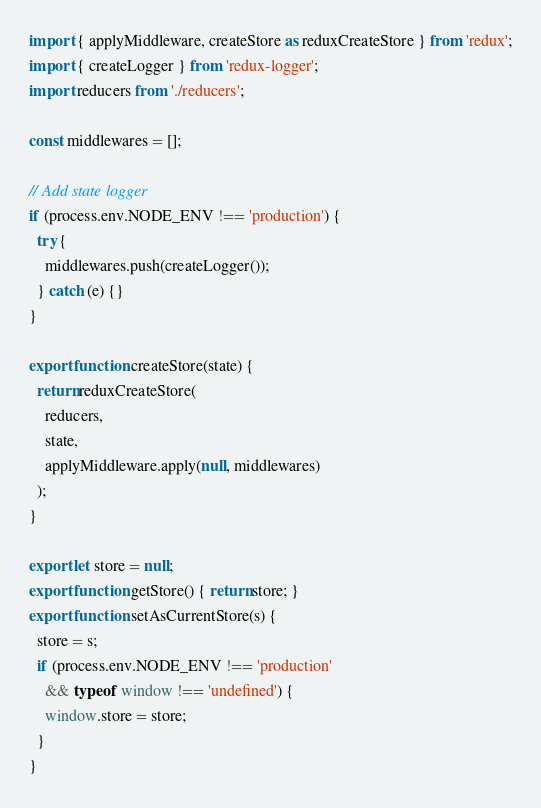<code> <loc_0><loc_0><loc_500><loc_500><_JavaScript_>import { applyMiddleware, createStore as reduxCreateStore } from 'redux';
import { createLogger } from 'redux-logger';
import reducers from './reducers';

const middlewares = [];

// Add state logger
if (process.env.NODE_ENV !== 'production') {
  try {
    middlewares.push(createLogger());
  } catch (e) {}
}

export function createStore(state) {
  return reduxCreateStore(
    reducers,
    state,
    applyMiddleware.apply(null, middlewares)
  );
}

export let store = null;
export function getStore() { return store; }
export function setAsCurrentStore(s) {
  store = s;
  if (process.env.NODE_ENV !== 'production'
    && typeof window !== 'undefined') {
    window.store = store;
  }
}
</code> 